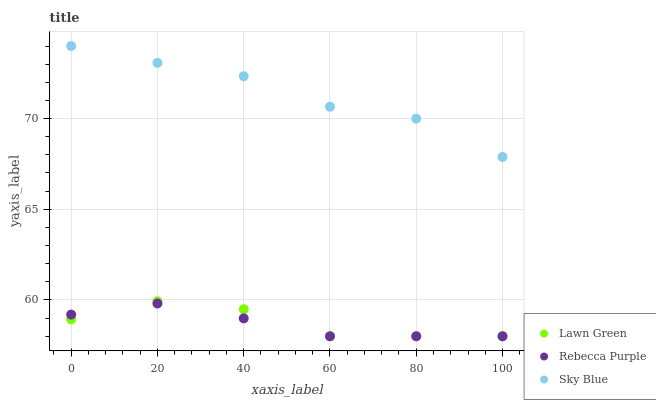Does Rebecca Purple have the minimum area under the curve?
Answer yes or no. Yes. Does Sky Blue have the maximum area under the curve?
Answer yes or no. Yes. Does Sky Blue have the minimum area under the curve?
Answer yes or no. No. Does Rebecca Purple have the maximum area under the curve?
Answer yes or no. No. Is Rebecca Purple the smoothest?
Answer yes or no. Yes. Is Lawn Green the roughest?
Answer yes or no. Yes. Is Sky Blue the smoothest?
Answer yes or no. No. Is Sky Blue the roughest?
Answer yes or no. No. Does Lawn Green have the lowest value?
Answer yes or no. Yes. Does Sky Blue have the lowest value?
Answer yes or no. No. Does Sky Blue have the highest value?
Answer yes or no. Yes. Does Rebecca Purple have the highest value?
Answer yes or no. No. Is Rebecca Purple less than Sky Blue?
Answer yes or no. Yes. Is Sky Blue greater than Rebecca Purple?
Answer yes or no. Yes. Does Rebecca Purple intersect Lawn Green?
Answer yes or no. Yes. Is Rebecca Purple less than Lawn Green?
Answer yes or no. No. Is Rebecca Purple greater than Lawn Green?
Answer yes or no. No. Does Rebecca Purple intersect Sky Blue?
Answer yes or no. No. 